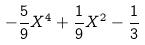Convert formula to latex. <formula><loc_0><loc_0><loc_500><loc_500>- \frac { 5 } { 9 } X ^ { 4 } + \frac { 1 } { 9 } X ^ { 2 } - \frac { 1 } { 3 }</formula> 